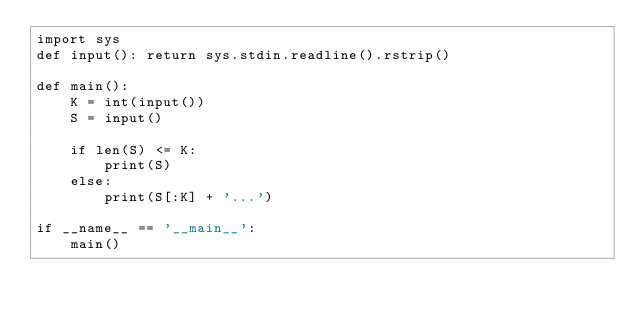Convert code to text. <code><loc_0><loc_0><loc_500><loc_500><_Python_>import sys
def input(): return sys.stdin.readline().rstrip()

def main():
    K = int(input())
    S = input()

    if len(S) <= K:
        print(S)
    else:
        print(S[:K] + '...')

if __name__ == '__main__':
    main()
</code> 